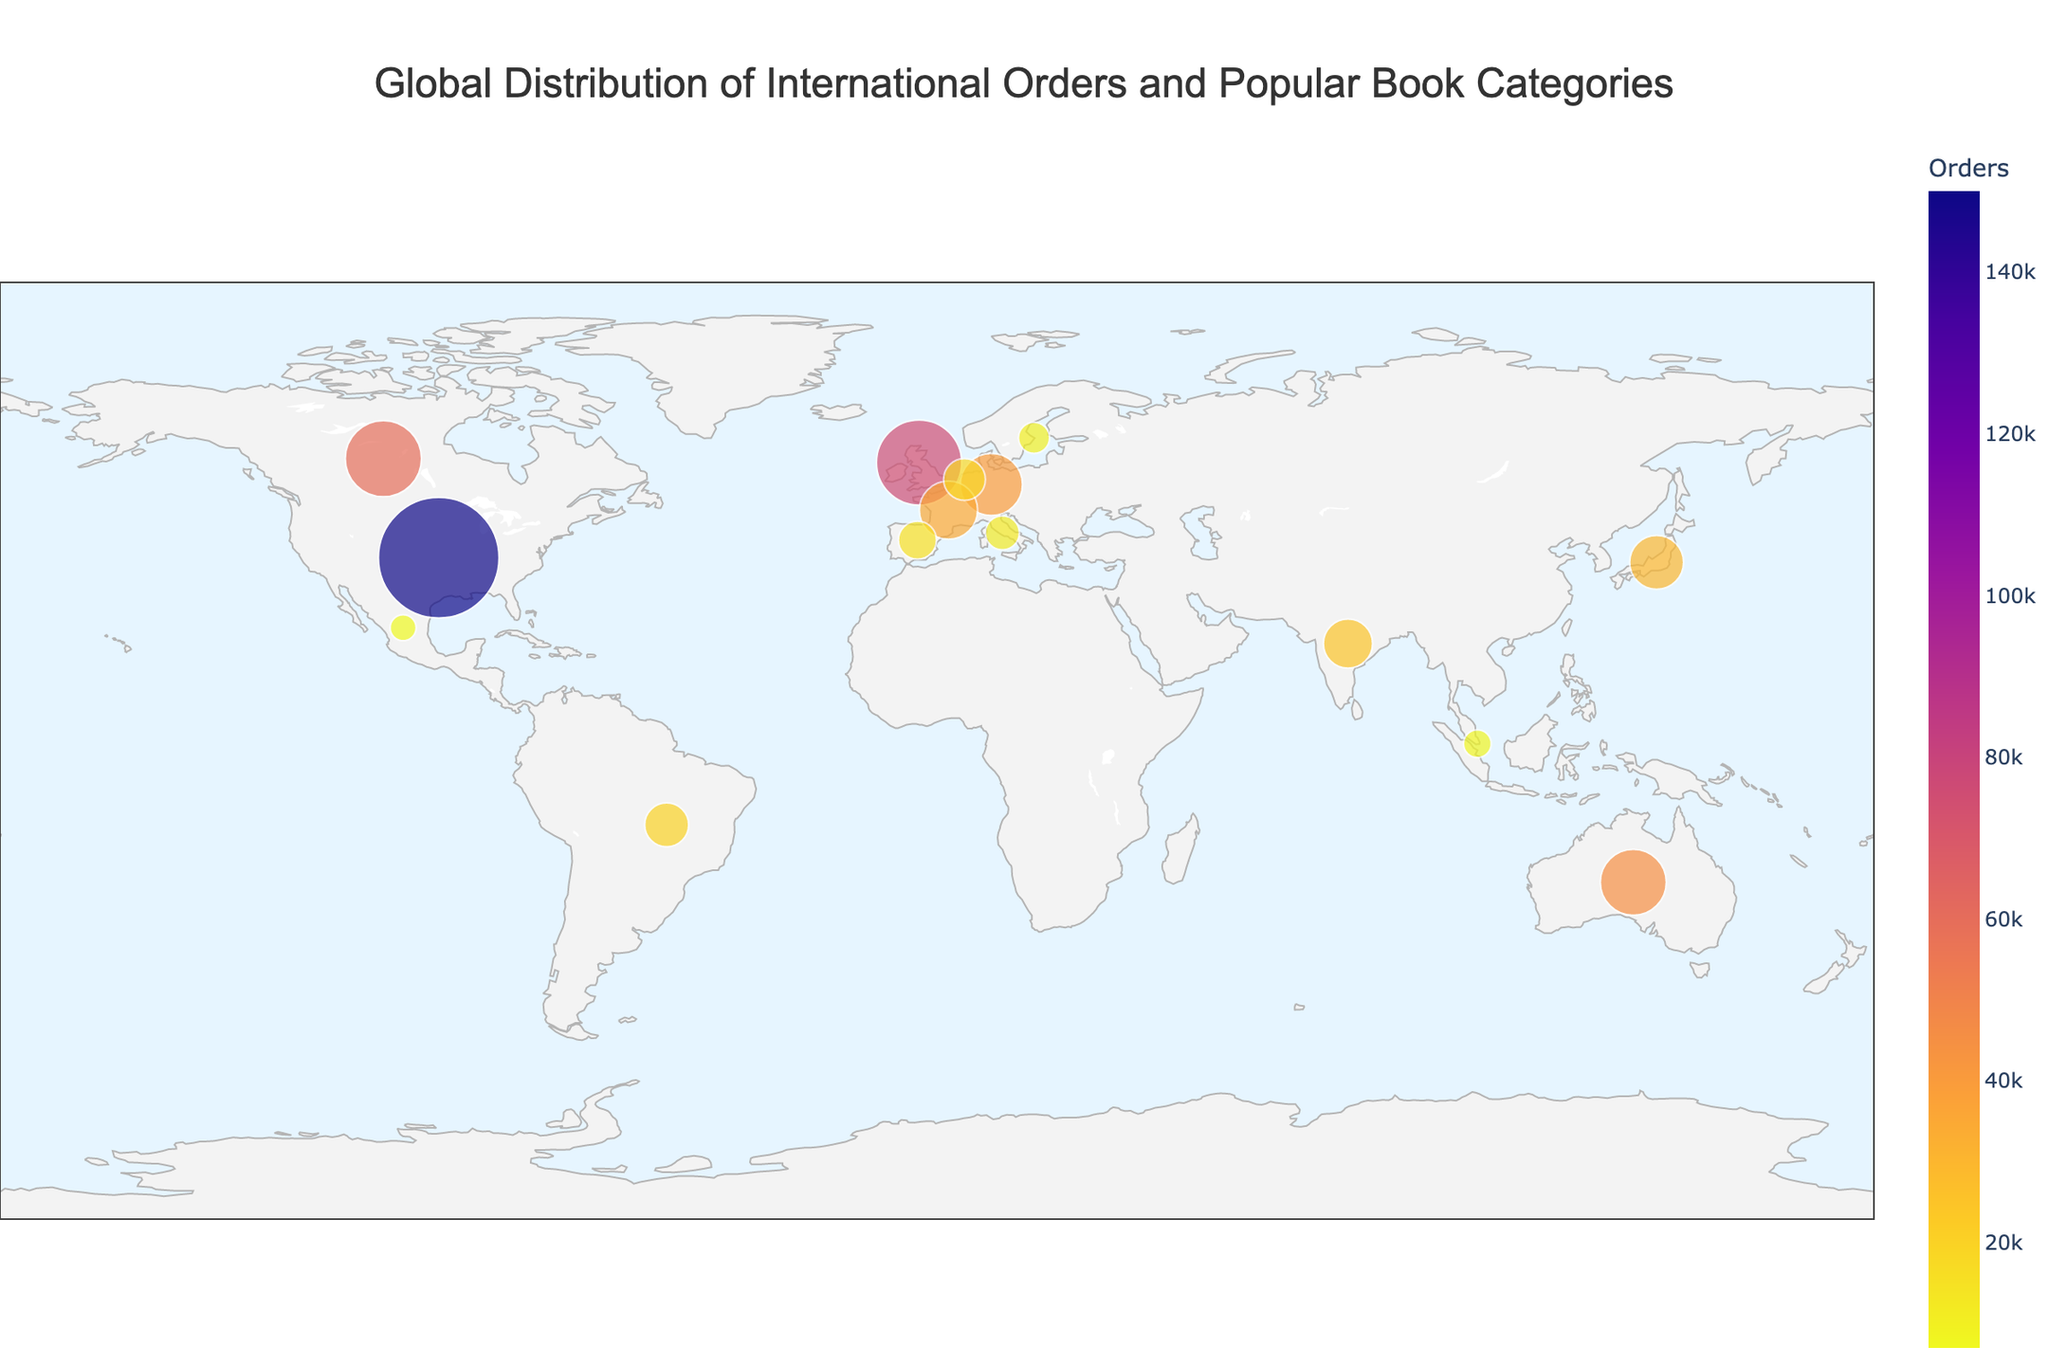How many countries are represented on the plot? There are markers on the plot, each representing a different country with associated orders and book categories. By counting the markers, we find there are 15 countries represented.
Answer: 15 Which country has the largest number of orders? The size of the markers on the plot represents the number of orders. The largest marker corresponds to the United States. The hover data also confirms that the United States has 150,000 orders, the largest number.
Answer: United States What is the most popular book category in Japan? By hovering over Japan on the plot, the hover data shows the most popular book category. For Japan, it is Manga.
Answer: Manga How many more orders does the United States have compared to Canada? The number of orders for the United States is 150,000 and for Canada, it is 60,000. The difference is 150,000 - 60,000 = 90,000.
Answer: 90,000 Which country in Asia has the least number of orders? For Asian countries in the plot (Japan, India, Singapore), the number of orders are 30,000, 25,000, and 8,000 respectively. Singapore has the least number of orders with 8,000.
Answer: Singapore What book category is most popular in European countries represented in the figure? European countries represented are United Kingdom, Germany, France, Netherlands, Spain, and Italy. Their top categories are Mystery, Non-fiction, Cookbooks, History, Travel, and Art respectively. These categories are all distinct, meaning there isn’t a repeated popular category among these European countries.
Answer: No single category Which country has the closest number of orders to Mexico? Mexico has 7,000 orders. By comparing this with other countries, Sweden has 10,000 orders, which is the closest number to Mexico's 7,000 orders.
Answer: Sweden What is the average number of orders for the countries in South America? The only South American country represented is Brazil with 20,000 orders. Since there is only one country, the average is the same as the number of orders for Brazil.
Answer: 20,000 Is Romance a more popular category than Science Fiction based on order counts? To compare these categories, look at the countries representing them: Australia (Romance) with 45,000 orders and Canada (Science Fiction) with 60,000 orders. Science Fiction has more orders than Romance.
Answer: No Which country has the smallest number of orders and what is its top book category? From the figure, Mexico has the smallest number of orders which is 7,000. The top book category for Mexico is Young Adult.
Answer: Mexico, Young Adult 